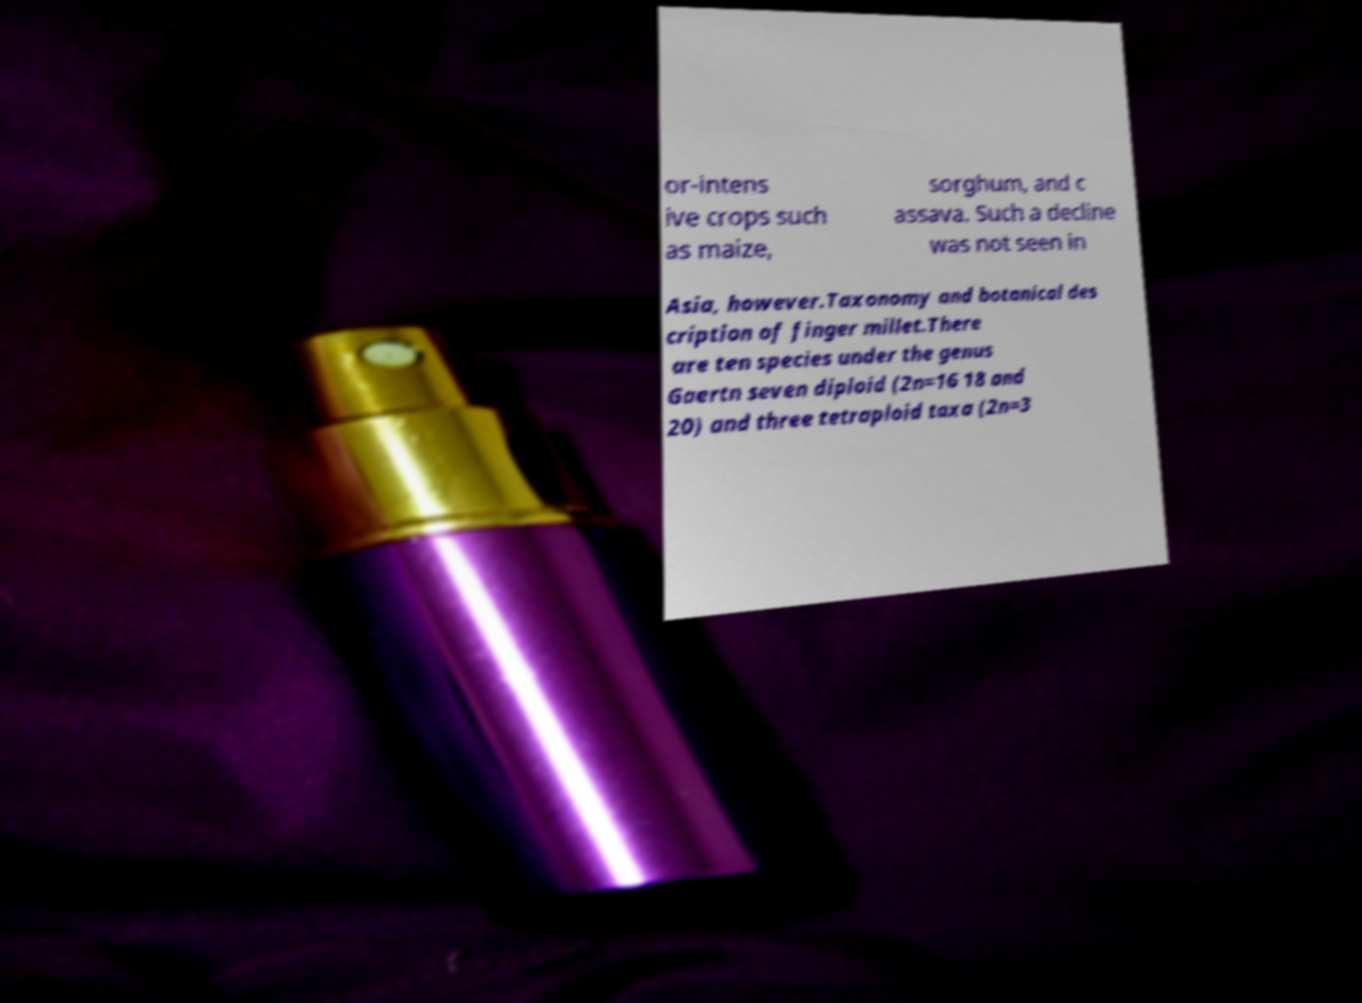Can you accurately transcribe the text from the provided image for me? or-intens ive crops such as maize, sorghum, and c assava. Such a decline was not seen in Asia, however.Taxonomy and botanical des cription of finger millet.There are ten species under the genus Gaertn seven diploid (2n=16 18 and 20) and three tetraploid taxa (2n=3 